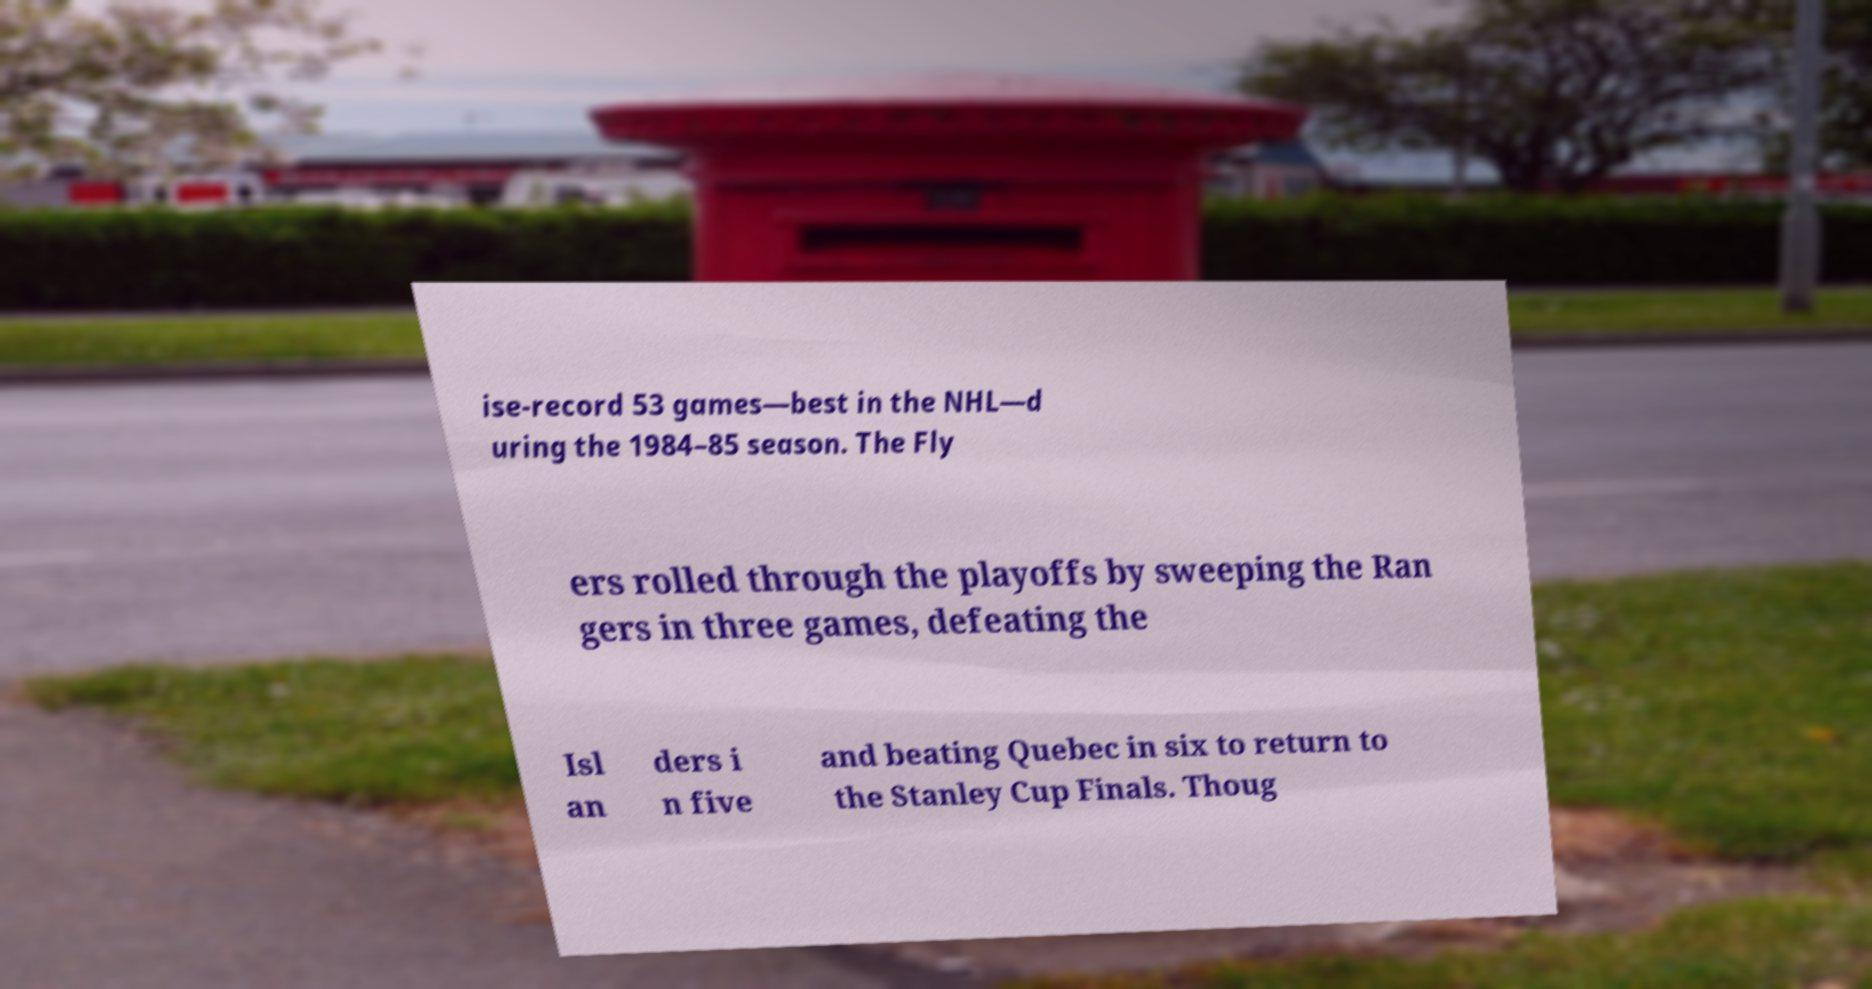Can you accurately transcribe the text from the provided image for me? ise-record 53 games—best in the NHL—d uring the 1984–85 season. The Fly ers rolled through the playoffs by sweeping the Ran gers in three games, defeating the Isl an ders i n five and beating Quebec in six to return to the Stanley Cup Finals. Thoug 